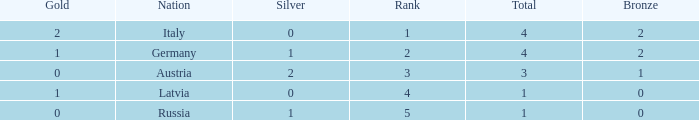What is the average gold medals for countries with more than 0 bronze, more than 0 silver, rank over 2 and total over 3? None. 